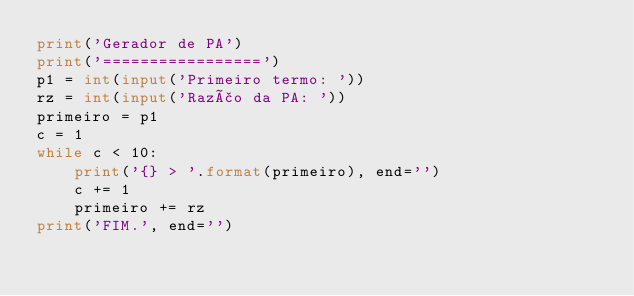<code> <loc_0><loc_0><loc_500><loc_500><_Python_>print('Gerador de PA')
print('=================')
p1 = int(input('Primeiro termo: '))
rz = int(input('Razão da PA: '))
primeiro = p1
c = 1
while c < 10:
    print('{} > '.format(primeiro), end='')
    c += 1
    primeiro += rz
print('FIM.', end='')
</code> 